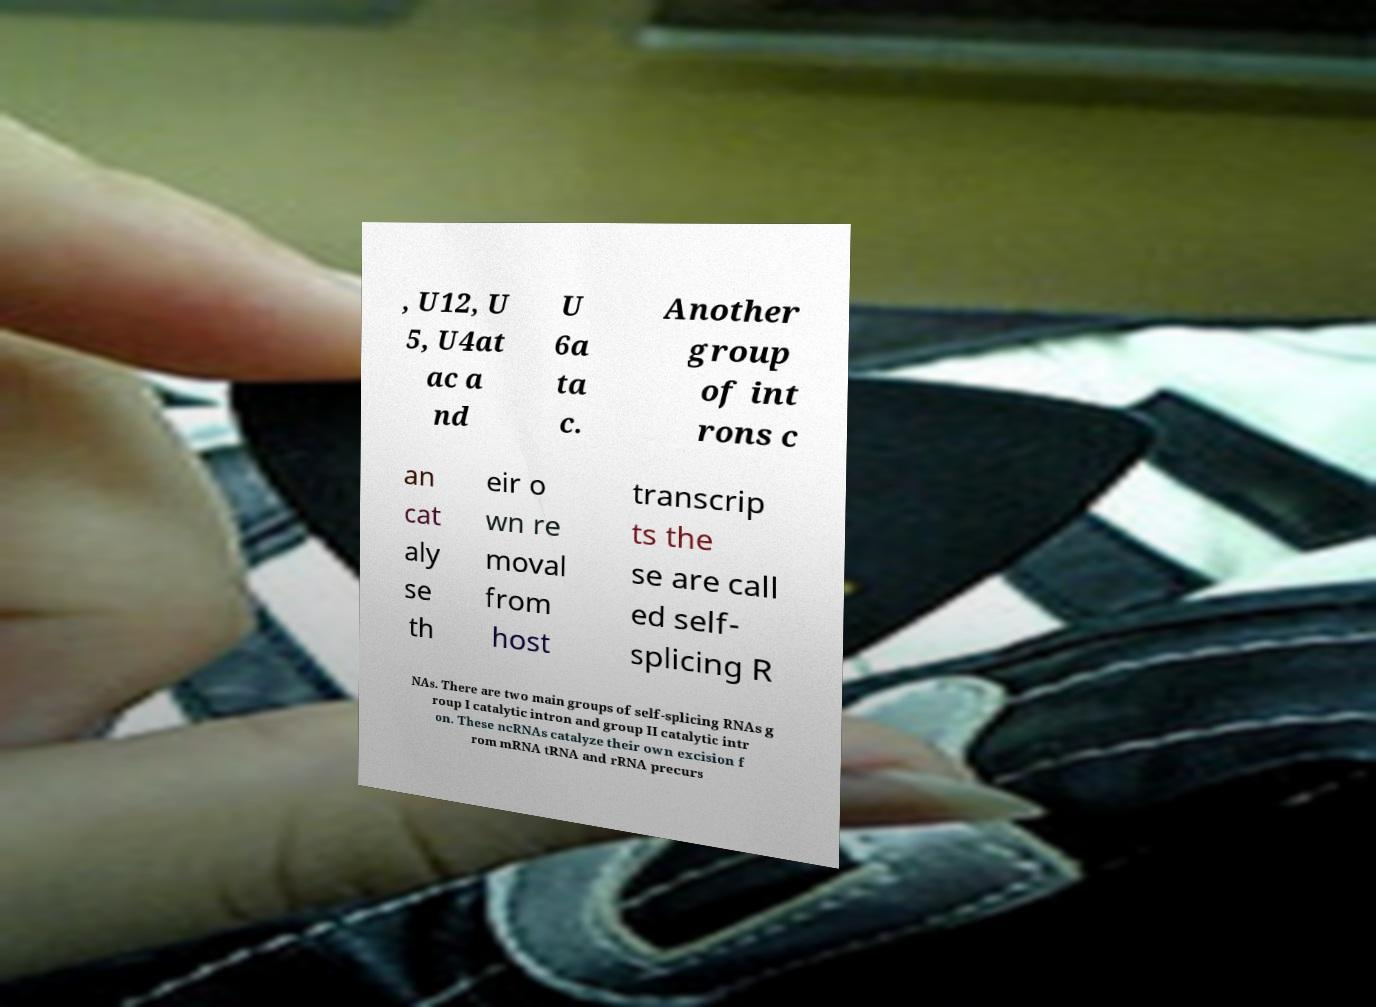Please read and relay the text visible in this image. What does it say? , U12, U 5, U4at ac a nd U 6a ta c. Another group of int rons c an cat aly se th eir o wn re moval from host transcrip ts the se are call ed self- splicing R NAs. There are two main groups of self-splicing RNAs g roup I catalytic intron and group II catalytic intr on. These ncRNAs catalyze their own excision f rom mRNA tRNA and rRNA precurs 